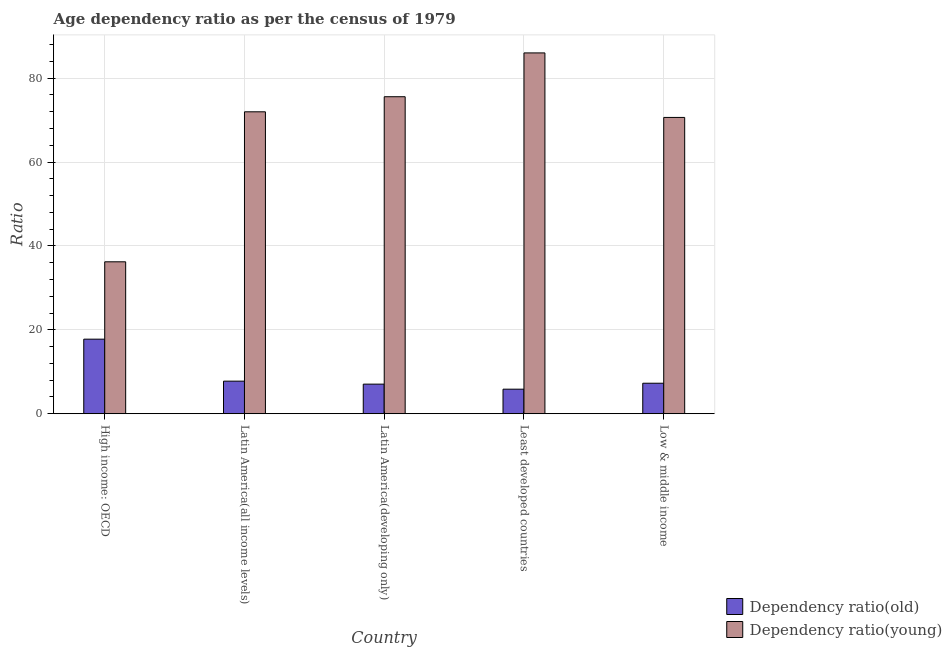How many different coloured bars are there?
Provide a short and direct response. 2. How many groups of bars are there?
Your response must be concise. 5. Are the number of bars per tick equal to the number of legend labels?
Ensure brevity in your answer.  Yes. Are the number of bars on each tick of the X-axis equal?
Provide a succinct answer. Yes. How many bars are there on the 1st tick from the left?
Offer a very short reply. 2. What is the label of the 4th group of bars from the left?
Give a very brief answer. Least developed countries. In how many cases, is the number of bars for a given country not equal to the number of legend labels?
Your answer should be very brief. 0. What is the age dependency ratio(old) in High income: OECD?
Your response must be concise. 17.78. Across all countries, what is the maximum age dependency ratio(old)?
Make the answer very short. 17.78. Across all countries, what is the minimum age dependency ratio(old)?
Offer a terse response. 5.86. In which country was the age dependency ratio(old) maximum?
Your answer should be very brief. High income: OECD. In which country was the age dependency ratio(young) minimum?
Make the answer very short. High income: OECD. What is the total age dependency ratio(old) in the graph?
Keep it short and to the point. 45.73. What is the difference between the age dependency ratio(young) in High income: OECD and that in Latin America(all income levels)?
Your answer should be compact. -35.76. What is the difference between the age dependency ratio(young) in High income: OECD and the age dependency ratio(old) in Latin America(developing only)?
Give a very brief answer. 29.16. What is the average age dependency ratio(young) per country?
Ensure brevity in your answer.  68.08. What is the difference between the age dependency ratio(old) and age dependency ratio(young) in High income: OECD?
Your answer should be very brief. -18.44. What is the ratio of the age dependency ratio(young) in High income: OECD to that in Low & middle income?
Your answer should be very brief. 0.51. What is the difference between the highest and the second highest age dependency ratio(old)?
Make the answer very short. 10.01. What is the difference between the highest and the lowest age dependency ratio(old)?
Make the answer very short. 11.92. What does the 1st bar from the left in Latin America(developing only) represents?
Your answer should be very brief. Dependency ratio(old). What does the 1st bar from the right in Least developed countries represents?
Keep it short and to the point. Dependency ratio(young). How many bars are there?
Your response must be concise. 10. How many countries are there in the graph?
Provide a succinct answer. 5. What is the difference between two consecutive major ticks on the Y-axis?
Your answer should be compact. 20. Are the values on the major ticks of Y-axis written in scientific E-notation?
Offer a very short reply. No. Where does the legend appear in the graph?
Offer a terse response. Bottom right. How are the legend labels stacked?
Your answer should be very brief. Vertical. What is the title of the graph?
Ensure brevity in your answer.  Age dependency ratio as per the census of 1979. What is the label or title of the X-axis?
Your response must be concise. Country. What is the label or title of the Y-axis?
Your answer should be very brief. Ratio. What is the Ratio in Dependency ratio(old) in High income: OECD?
Keep it short and to the point. 17.78. What is the Ratio in Dependency ratio(young) in High income: OECD?
Keep it short and to the point. 36.22. What is the Ratio in Dependency ratio(old) in Latin America(all income levels)?
Offer a terse response. 7.77. What is the Ratio in Dependency ratio(young) in Latin America(all income levels)?
Your answer should be compact. 71.98. What is the Ratio of Dependency ratio(old) in Latin America(developing only)?
Provide a short and direct response. 7.06. What is the Ratio in Dependency ratio(young) in Latin America(developing only)?
Offer a terse response. 75.57. What is the Ratio in Dependency ratio(old) in Least developed countries?
Give a very brief answer. 5.86. What is the Ratio of Dependency ratio(young) in Least developed countries?
Provide a short and direct response. 86.01. What is the Ratio in Dependency ratio(old) in Low & middle income?
Provide a succinct answer. 7.27. What is the Ratio in Dependency ratio(young) in Low & middle income?
Offer a very short reply. 70.64. Across all countries, what is the maximum Ratio of Dependency ratio(old)?
Provide a succinct answer. 17.78. Across all countries, what is the maximum Ratio of Dependency ratio(young)?
Make the answer very short. 86.01. Across all countries, what is the minimum Ratio of Dependency ratio(old)?
Offer a terse response. 5.86. Across all countries, what is the minimum Ratio in Dependency ratio(young)?
Your answer should be very brief. 36.22. What is the total Ratio of Dependency ratio(old) in the graph?
Offer a terse response. 45.73. What is the total Ratio of Dependency ratio(young) in the graph?
Give a very brief answer. 340.41. What is the difference between the Ratio in Dependency ratio(old) in High income: OECD and that in Latin America(all income levels)?
Keep it short and to the point. 10.01. What is the difference between the Ratio in Dependency ratio(young) in High income: OECD and that in Latin America(all income levels)?
Provide a short and direct response. -35.76. What is the difference between the Ratio in Dependency ratio(old) in High income: OECD and that in Latin America(developing only)?
Offer a terse response. 10.72. What is the difference between the Ratio of Dependency ratio(young) in High income: OECD and that in Latin America(developing only)?
Offer a very short reply. -39.35. What is the difference between the Ratio in Dependency ratio(old) in High income: OECD and that in Least developed countries?
Keep it short and to the point. 11.92. What is the difference between the Ratio of Dependency ratio(young) in High income: OECD and that in Least developed countries?
Keep it short and to the point. -49.8. What is the difference between the Ratio in Dependency ratio(old) in High income: OECD and that in Low & middle income?
Give a very brief answer. 10.5. What is the difference between the Ratio in Dependency ratio(young) in High income: OECD and that in Low & middle income?
Keep it short and to the point. -34.42. What is the difference between the Ratio of Dependency ratio(old) in Latin America(all income levels) and that in Latin America(developing only)?
Ensure brevity in your answer.  0.71. What is the difference between the Ratio in Dependency ratio(young) in Latin America(all income levels) and that in Latin America(developing only)?
Provide a succinct answer. -3.6. What is the difference between the Ratio of Dependency ratio(old) in Latin America(all income levels) and that in Least developed countries?
Your answer should be compact. 1.91. What is the difference between the Ratio of Dependency ratio(young) in Latin America(all income levels) and that in Least developed countries?
Give a very brief answer. -14.04. What is the difference between the Ratio in Dependency ratio(old) in Latin America(all income levels) and that in Low & middle income?
Ensure brevity in your answer.  0.5. What is the difference between the Ratio in Dependency ratio(young) in Latin America(all income levels) and that in Low & middle income?
Offer a terse response. 1.34. What is the difference between the Ratio in Dependency ratio(old) in Latin America(developing only) and that in Least developed countries?
Keep it short and to the point. 1.2. What is the difference between the Ratio in Dependency ratio(young) in Latin America(developing only) and that in Least developed countries?
Keep it short and to the point. -10.44. What is the difference between the Ratio in Dependency ratio(old) in Latin America(developing only) and that in Low & middle income?
Provide a succinct answer. -0.22. What is the difference between the Ratio of Dependency ratio(young) in Latin America(developing only) and that in Low & middle income?
Offer a very short reply. 4.94. What is the difference between the Ratio in Dependency ratio(old) in Least developed countries and that in Low & middle income?
Provide a short and direct response. -1.42. What is the difference between the Ratio in Dependency ratio(young) in Least developed countries and that in Low & middle income?
Offer a very short reply. 15.38. What is the difference between the Ratio in Dependency ratio(old) in High income: OECD and the Ratio in Dependency ratio(young) in Latin America(all income levels)?
Your response must be concise. -54.2. What is the difference between the Ratio of Dependency ratio(old) in High income: OECD and the Ratio of Dependency ratio(young) in Latin America(developing only)?
Offer a terse response. -57.79. What is the difference between the Ratio of Dependency ratio(old) in High income: OECD and the Ratio of Dependency ratio(young) in Least developed countries?
Provide a short and direct response. -68.24. What is the difference between the Ratio in Dependency ratio(old) in High income: OECD and the Ratio in Dependency ratio(young) in Low & middle income?
Keep it short and to the point. -52.86. What is the difference between the Ratio of Dependency ratio(old) in Latin America(all income levels) and the Ratio of Dependency ratio(young) in Latin America(developing only)?
Make the answer very short. -67.8. What is the difference between the Ratio of Dependency ratio(old) in Latin America(all income levels) and the Ratio of Dependency ratio(young) in Least developed countries?
Provide a short and direct response. -78.24. What is the difference between the Ratio in Dependency ratio(old) in Latin America(all income levels) and the Ratio in Dependency ratio(young) in Low & middle income?
Keep it short and to the point. -62.86. What is the difference between the Ratio of Dependency ratio(old) in Latin America(developing only) and the Ratio of Dependency ratio(young) in Least developed countries?
Ensure brevity in your answer.  -78.96. What is the difference between the Ratio in Dependency ratio(old) in Latin America(developing only) and the Ratio in Dependency ratio(young) in Low & middle income?
Provide a succinct answer. -63.58. What is the difference between the Ratio of Dependency ratio(old) in Least developed countries and the Ratio of Dependency ratio(young) in Low & middle income?
Make the answer very short. -64.78. What is the average Ratio of Dependency ratio(old) per country?
Keep it short and to the point. 9.15. What is the average Ratio in Dependency ratio(young) per country?
Ensure brevity in your answer.  68.08. What is the difference between the Ratio of Dependency ratio(old) and Ratio of Dependency ratio(young) in High income: OECD?
Make the answer very short. -18.44. What is the difference between the Ratio of Dependency ratio(old) and Ratio of Dependency ratio(young) in Latin America(all income levels)?
Provide a short and direct response. -64.2. What is the difference between the Ratio in Dependency ratio(old) and Ratio in Dependency ratio(young) in Latin America(developing only)?
Make the answer very short. -68.52. What is the difference between the Ratio of Dependency ratio(old) and Ratio of Dependency ratio(young) in Least developed countries?
Your response must be concise. -80.16. What is the difference between the Ratio in Dependency ratio(old) and Ratio in Dependency ratio(young) in Low & middle income?
Ensure brevity in your answer.  -63.36. What is the ratio of the Ratio in Dependency ratio(old) in High income: OECD to that in Latin America(all income levels)?
Provide a short and direct response. 2.29. What is the ratio of the Ratio in Dependency ratio(young) in High income: OECD to that in Latin America(all income levels)?
Your response must be concise. 0.5. What is the ratio of the Ratio in Dependency ratio(old) in High income: OECD to that in Latin America(developing only)?
Provide a short and direct response. 2.52. What is the ratio of the Ratio in Dependency ratio(young) in High income: OECD to that in Latin America(developing only)?
Your response must be concise. 0.48. What is the ratio of the Ratio of Dependency ratio(old) in High income: OECD to that in Least developed countries?
Your answer should be very brief. 3.04. What is the ratio of the Ratio of Dependency ratio(young) in High income: OECD to that in Least developed countries?
Your response must be concise. 0.42. What is the ratio of the Ratio in Dependency ratio(old) in High income: OECD to that in Low & middle income?
Keep it short and to the point. 2.44. What is the ratio of the Ratio of Dependency ratio(young) in High income: OECD to that in Low & middle income?
Keep it short and to the point. 0.51. What is the ratio of the Ratio in Dependency ratio(old) in Latin America(all income levels) to that in Latin America(developing only)?
Offer a terse response. 1.1. What is the ratio of the Ratio in Dependency ratio(old) in Latin America(all income levels) to that in Least developed countries?
Give a very brief answer. 1.33. What is the ratio of the Ratio in Dependency ratio(young) in Latin America(all income levels) to that in Least developed countries?
Provide a succinct answer. 0.84. What is the ratio of the Ratio of Dependency ratio(old) in Latin America(all income levels) to that in Low & middle income?
Your answer should be very brief. 1.07. What is the ratio of the Ratio of Dependency ratio(old) in Latin America(developing only) to that in Least developed countries?
Your answer should be very brief. 1.2. What is the ratio of the Ratio in Dependency ratio(young) in Latin America(developing only) to that in Least developed countries?
Make the answer very short. 0.88. What is the ratio of the Ratio of Dependency ratio(old) in Latin America(developing only) to that in Low & middle income?
Give a very brief answer. 0.97. What is the ratio of the Ratio in Dependency ratio(young) in Latin America(developing only) to that in Low & middle income?
Offer a very short reply. 1.07. What is the ratio of the Ratio of Dependency ratio(old) in Least developed countries to that in Low & middle income?
Offer a terse response. 0.81. What is the ratio of the Ratio in Dependency ratio(young) in Least developed countries to that in Low & middle income?
Give a very brief answer. 1.22. What is the difference between the highest and the second highest Ratio in Dependency ratio(old)?
Keep it short and to the point. 10.01. What is the difference between the highest and the second highest Ratio in Dependency ratio(young)?
Make the answer very short. 10.44. What is the difference between the highest and the lowest Ratio in Dependency ratio(old)?
Give a very brief answer. 11.92. What is the difference between the highest and the lowest Ratio in Dependency ratio(young)?
Offer a terse response. 49.8. 